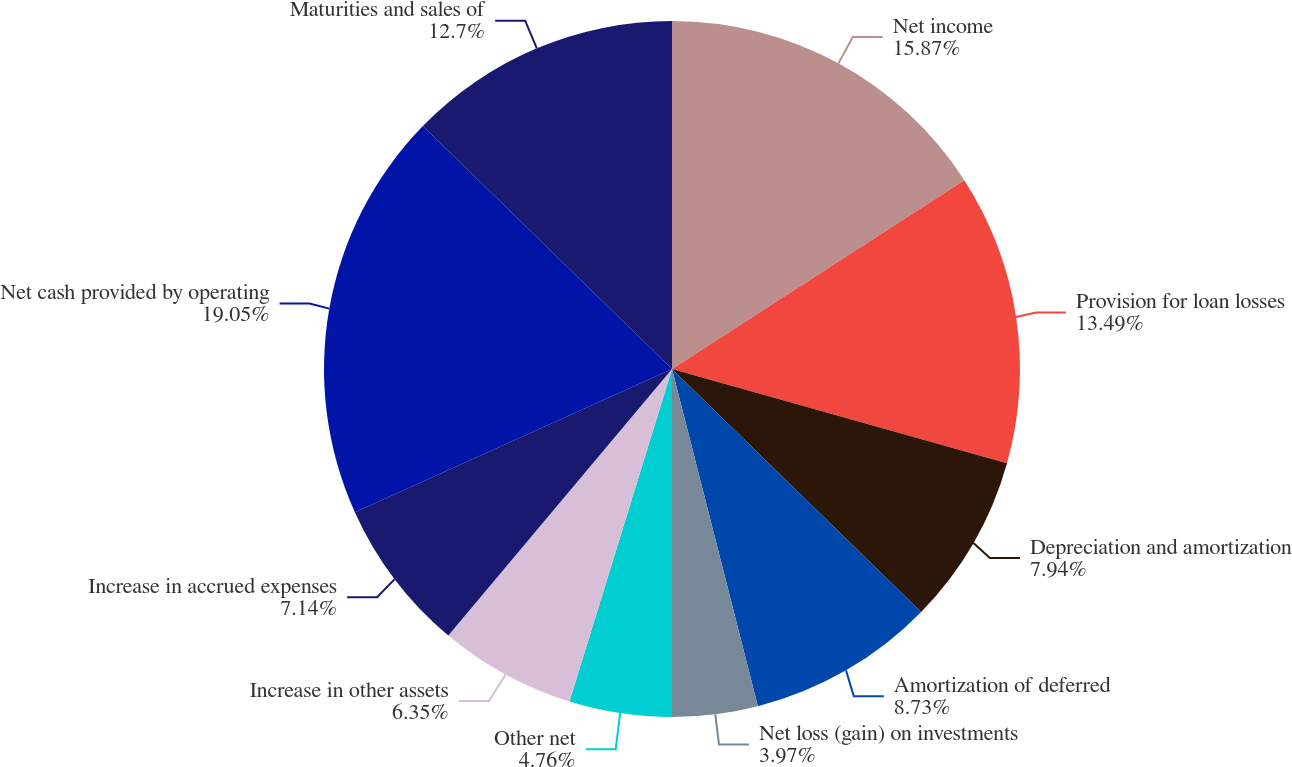<chart> <loc_0><loc_0><loc_500><loc_500><pie_chart><fcel>Net income<fcel>Provision for loan losses<fcel>Depreciation and amortization<fcel>Amortization of deferred<fcel>Net loss (gain) on investments<fcel>Other net<fcel>Increase in other assets<fcel>Increase in accrued expenses<fcel>Net cash provided by operating<fcel>Maturities and sales of<nl><fcel>15.87%<fcel>13.49%<fcel>7.94%<fcel>8.73%<fcel>3.97%<fcel>4.76%<fcel>6.35%<fcel>7.14%<fcel>19.05%<fcel>12.7%<nl></chart> 